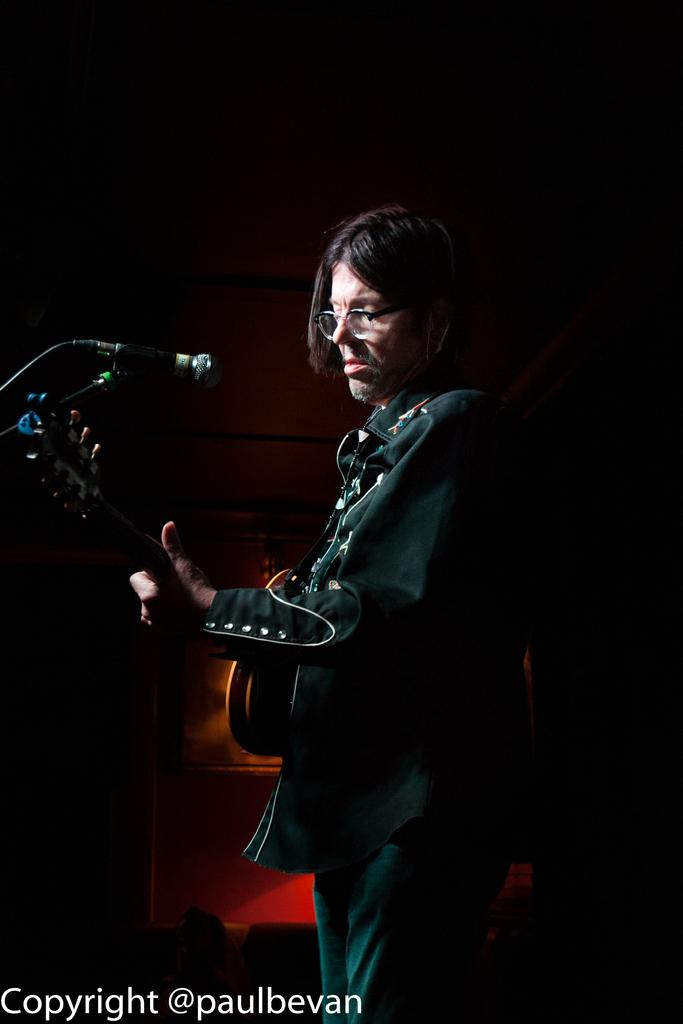Who is present in the image? There is a man in the image. What is the man doing in the image? The man is standing in the image. What object is the man holding in his hand? The man is holding a guitar in his hand. What can be seen in the background of the image? There is a wall in the background of the image. What is located on the left side of the image? There is a microphone on the left side of the image. What type of kettle is being used by the spy in the image? There is no kettle or spy present in the image. What things can be seen in the image besides the man and the guitar? The image only shows a man standing with a guitar and a microphone on the left side, along with a wall in the background. There are no other visible "things" mentioned in the provided facts. 